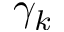Convert formula to latex. <formula><loc_0><loc_0><loc_500><loc_500>\gamma _ { k }</formula> 